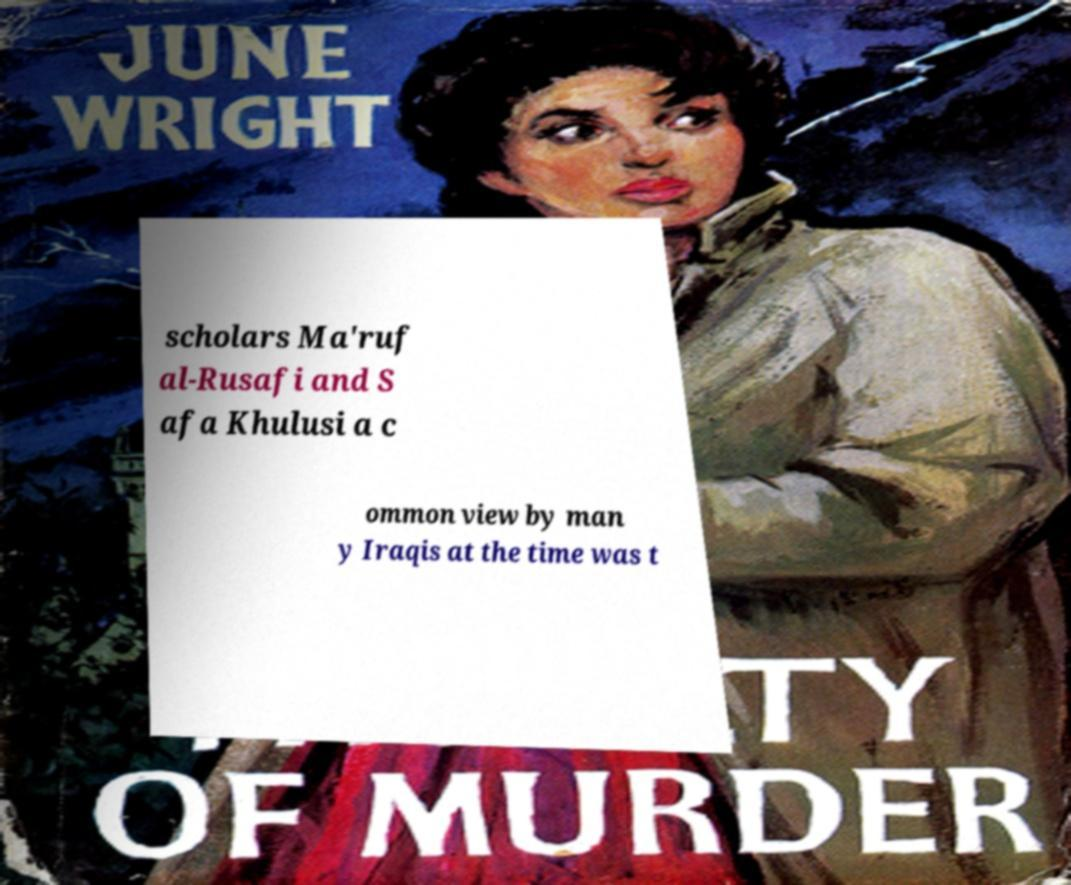Can you read and provide the text displayed in the image?This photo seems to have some interesting text. Can you extract and type it out for me? scholars Ma'ruf al-Rusafi and S afa Khulusi a c ommon view by man y Iraqis at the time was t 